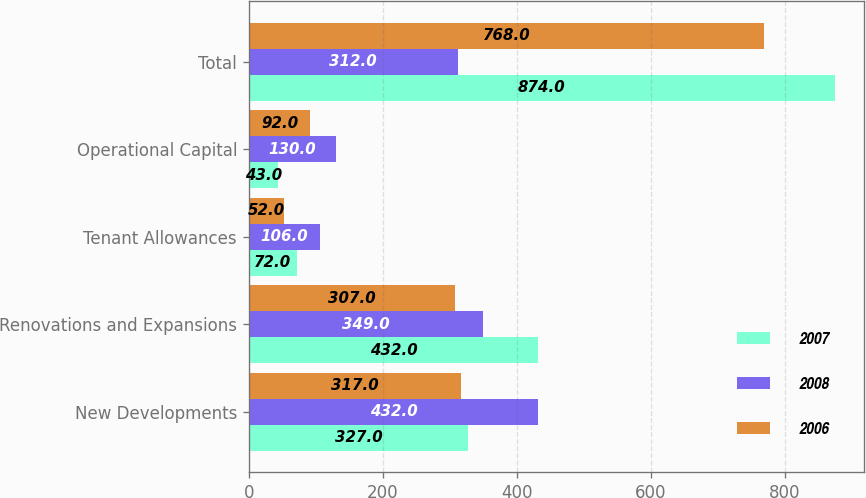Convert chart. <chart><loc_0><loc_0><loc_500><loc_500><stacked_bar_chart><ecel><fcel>New Developments<fcel>Renovations and Expansions<fcel>Tenant Allowances<fcel>Operational Capital<fcel>Total<nl><fcel>2007<fcel>327<fcel>432<fcel>72<fcel>43<fcel>874<nl><fcel>2008<fcel>432<fcel>349<fcel>106<fcel>130<fcel>312<nl><fcel>2006<fcel>317<fcel>307<fcel>52<fcel>92<fcel>768<nl></chart> 